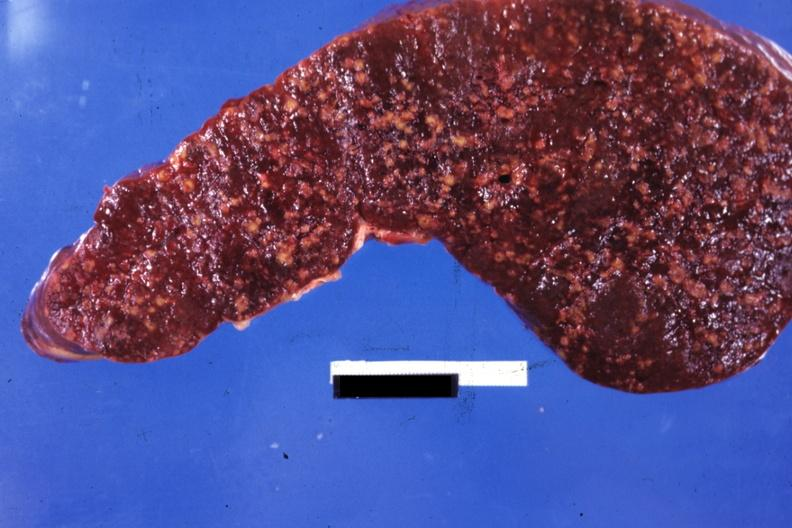s spleen present?
Answer the question using a single word or phrase. Yes 